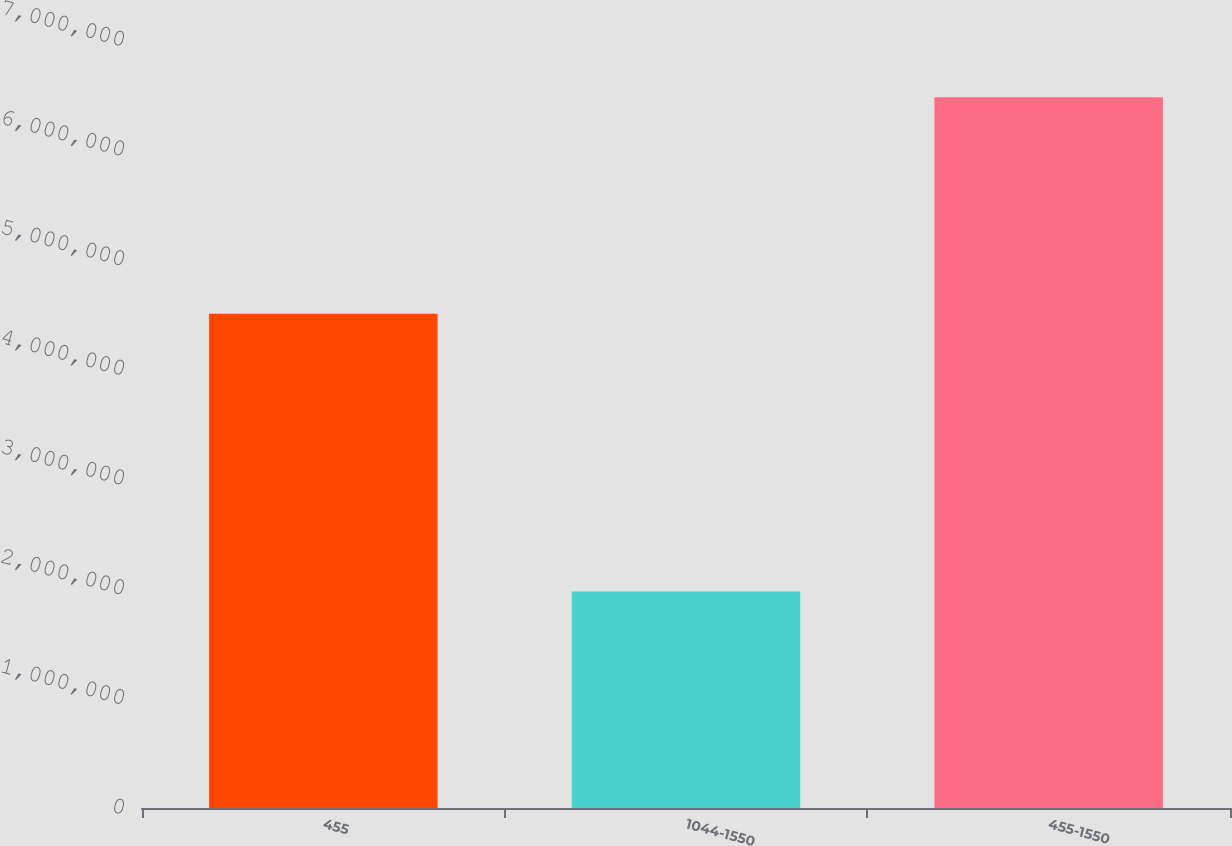Convert chart to OTSL. <chart><loc_0><loc_0><loc_500><loc_500><bar_chart><fcel>455<fcel>1044-1550<fcel>455-1550<nl><fcel>4.50562e+06<fcel>1.97282e+06<fcel>6.47844e+06<nl></chart> 